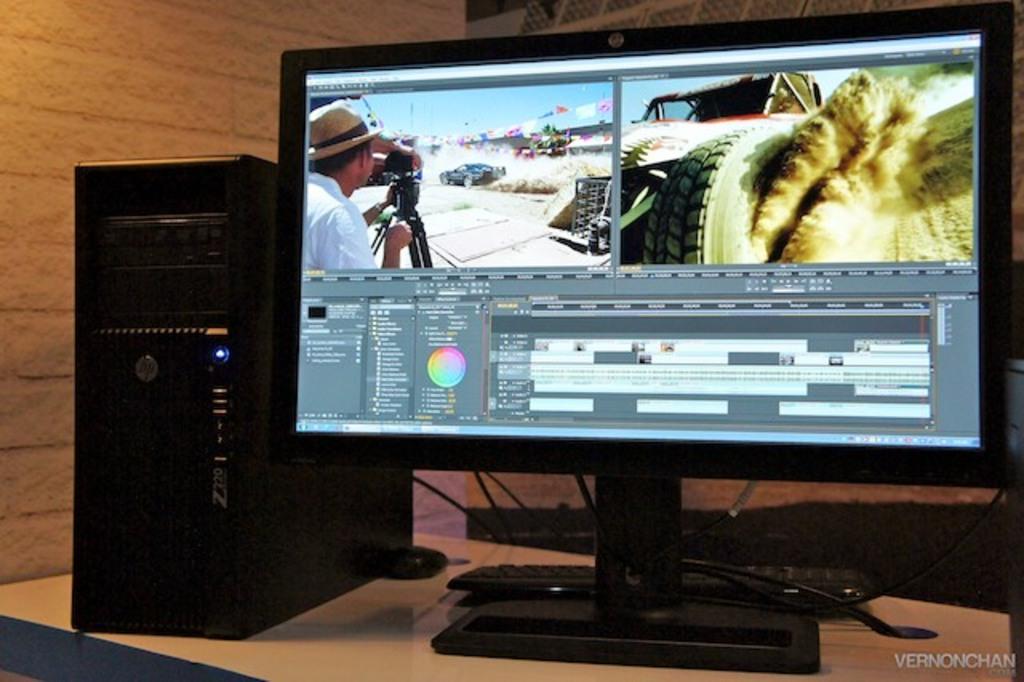What brand is this pc?
Offer a very short reply. Hp. What is watermarked on the bottom right of the image?
Your answer should be compact. Vernonchan. 